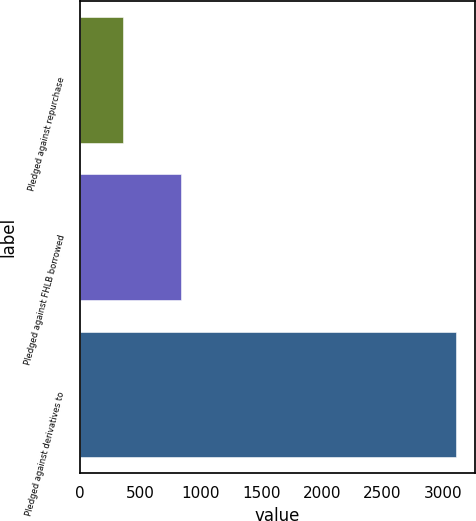Convert chart. <chart><loc_0><loc_0><loc_500><loc_500><bar_chart><fcel>Pledged against repurchase<fcel>Pledged against FHLB borrowed<fcel>Pledged against derivatives to<nl><fcel>358<fcel>839<fcel>3113<nl></chart> 